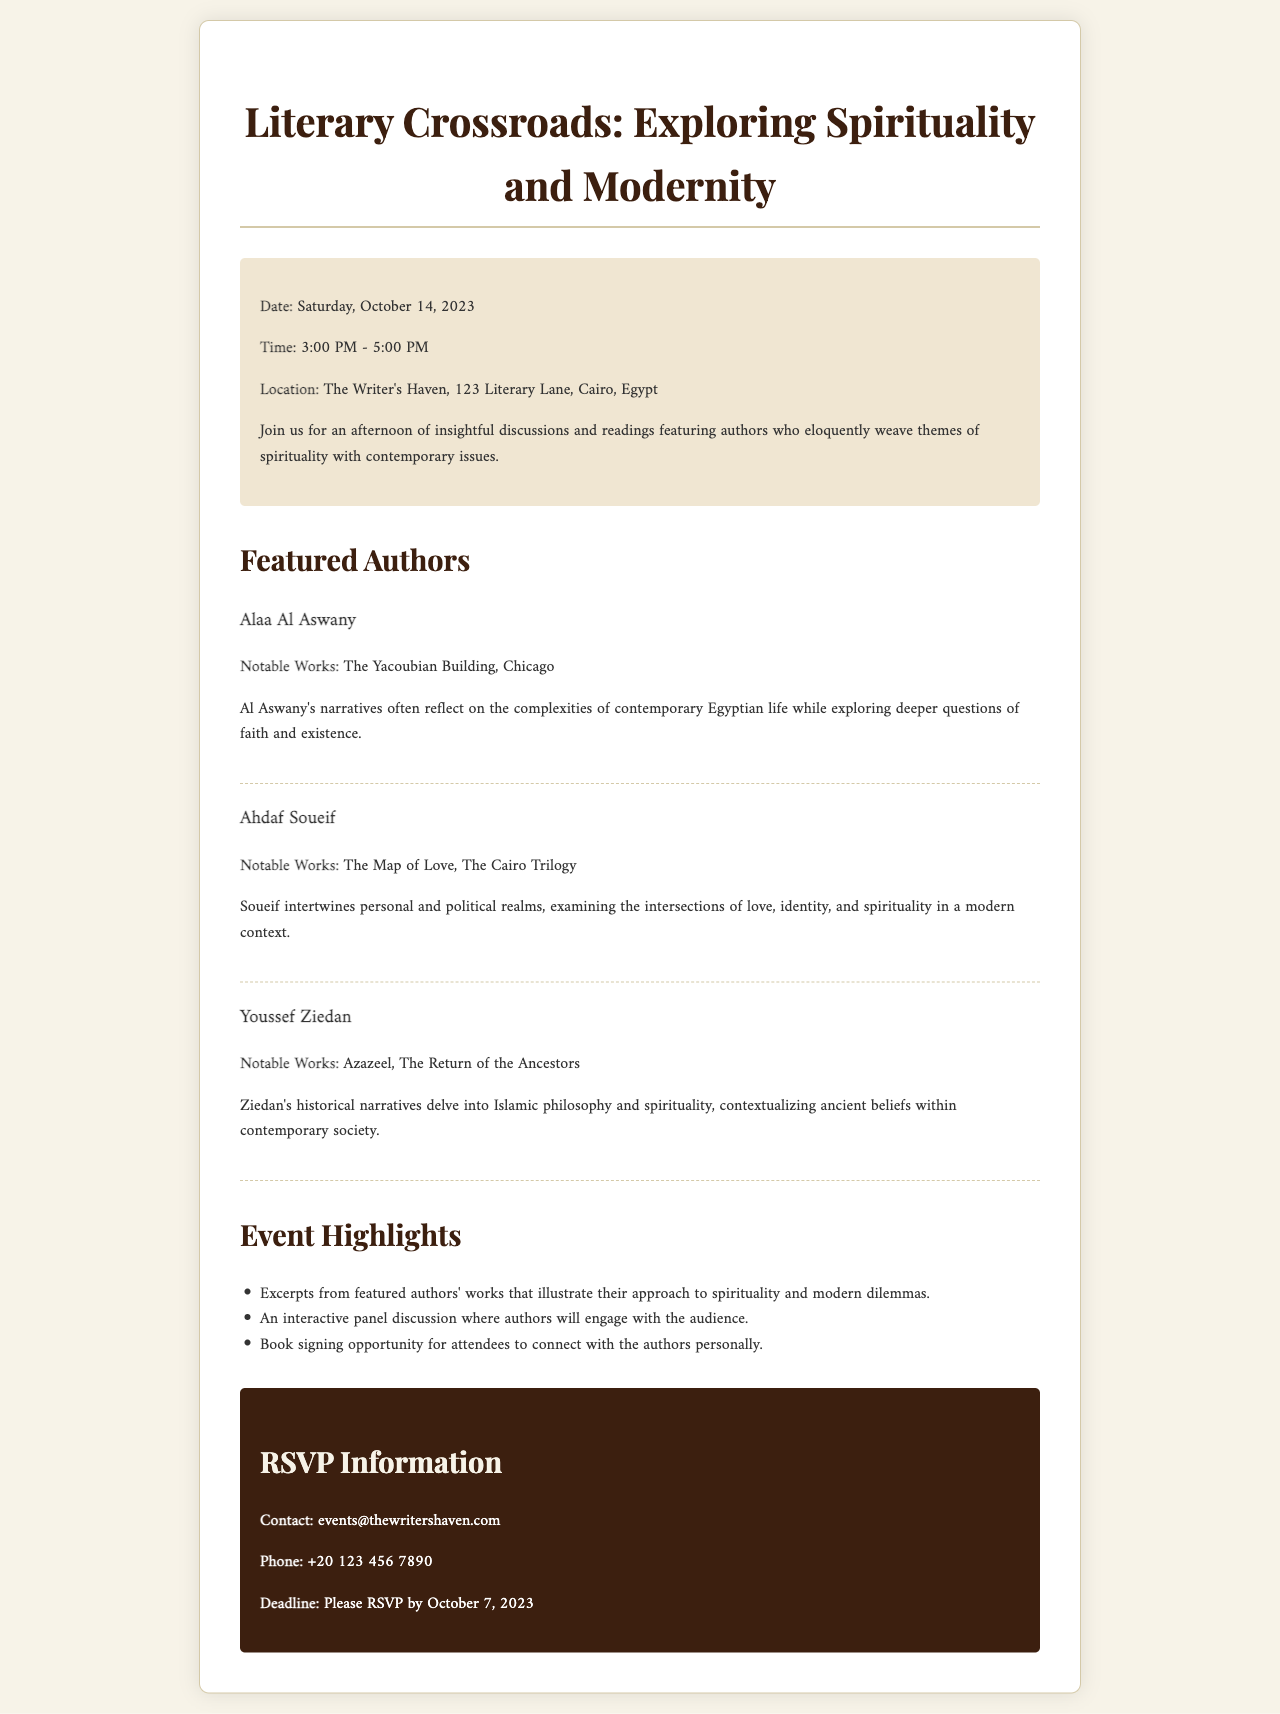What is the date of the event? The date of the event is explicitly stated in the document as Saturday, October 14, 2023.
Answer: Saturday, October 14, 2023 What is the time duration of the event? The time for the event is given as 3:00 PM - 5:00 PM.
Answer: 3:00 PM - 5:00 PM Where is the event located? The location of the event is clearly mentioned in the details as The Writer's Haven, 123 Literary Lane, Cairo, Egypt.
Answer: The Writer's Haven, 123 Literary Lane, Cairo, Egypt Who is one of the featured authors? The document lists several authors; one of them is Alaa Al Aswany.
Answer: Alaa Al Aswany What are the notable works of Ahdaf Soueif? The notable works of Ahdaf Soueif are specified as The Map of Love and The Cairo Trilogy.
Answer: The Map of Love, The Cairo Trilogy What type of discussions will be held during the event? The event features insightful discussions and readings that explore spirituality and contemporary issues.
Answer: Insights into spirituality and contemporary issues When is the RSVP deadline? The RSVP deadline is specified in the document as October 7, 2023.
Answer: October 7, 2023 What opportunity will attendees have at the event? Attendees will have a book signing opportunity to connect with the authors personally.
Answer: Book signing opportunity How can attendees contact for RSVP? The document provides an email as the primary contact method for RSVP, which is events@thewritershaven.com.
Answer: events@thewritershaven.com 